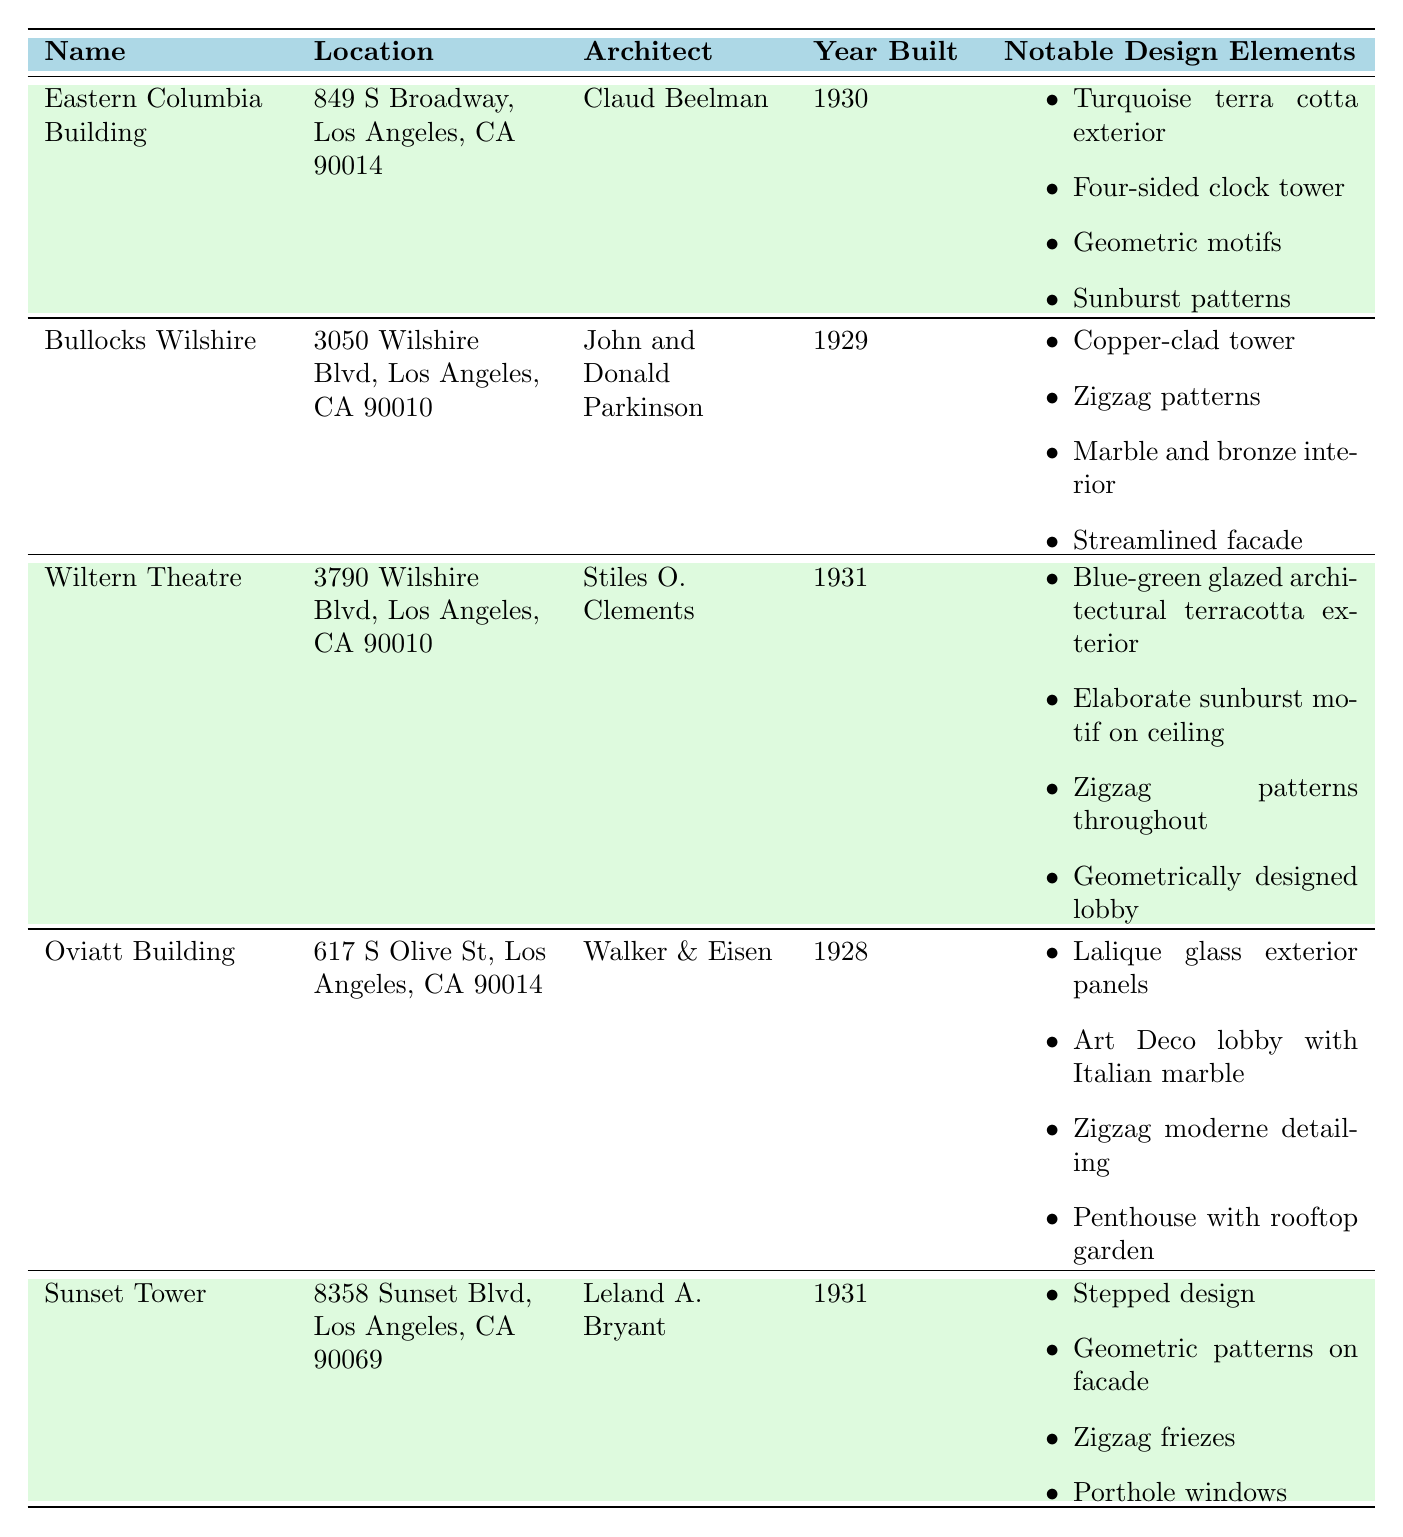What is the address of the Eastern Columbia Building? The address is specified in the table alongside the name of the building. For the Eastern Columbia Building, it is listed as 849 S Broadway, Los Angeles, CA 90014.
Answer: 849 S Broadway, Los Angeles, CA 90014 Who was the architect of Bullocks Wilshire? The architect is mentioned in the corresponding row for the Bullocks Wilshire entry. It is attributed to John and Donald Parkinson.
Answer: John and Donald Parkinson How many Art Deco buildings were built in the 1930s according to the table? We can count the buildings listed: the Eastern Columbia Building (1930), Wiltern Theatre (1931), and Sunset Tower (1931) were built in the 1930s, totaling three buildings.
Answer: 3 Does the Oviatt Building feature a rooftop garden? The notable design elements list includes "Penthouse with rooftop garden," confirming that it does indeed have this feature.
Answer: Yes Which of the buildings has a geometric motif as part of its design elements? By reviewing the notable design elements, both the Eastern Columbia Building and the Wiltern Theatre mention geometric motifs. Therefore, it's important to note all relevant buildings.
Answer: Eastern Columbia Building and Wiltern Theatre What is the year difference between the Eastern Columbia Building and the Oviatt Building? The Eastern Columbia Building was built in 1930 and the Oviatt Building in 1928. The difference is calculated as 1930 - 1928 = 2 years.
Answer: 2 years Which building has copper-clad construction and who is its architect? The Bullocks Wilshire is noted for its "Copper-clad tower," and the architect is listed as John and Donald Parkinson.
Answer: Bullocks Wilshire, John and Donald Parkinson How many distinctive design elements does the Sunset Tower have? The table lists four notable elements for the Sunset Tower, providing a clear count of its design features.
Answer: 4 Is the Wiltern Theatre's exterior made of blue-green glazed terracotta? The details confirm that the Wiltern Theatre’s notable design elements include "Blue-green glazed architectural terracotta exterior," confirming this characteristic.
Answer: Yes Which building was designed by Stiles O. Clements? The Wiltern Theatre is specified in the table as designed by Stiles O. Clements.
Answer: Wiltern Theatre 